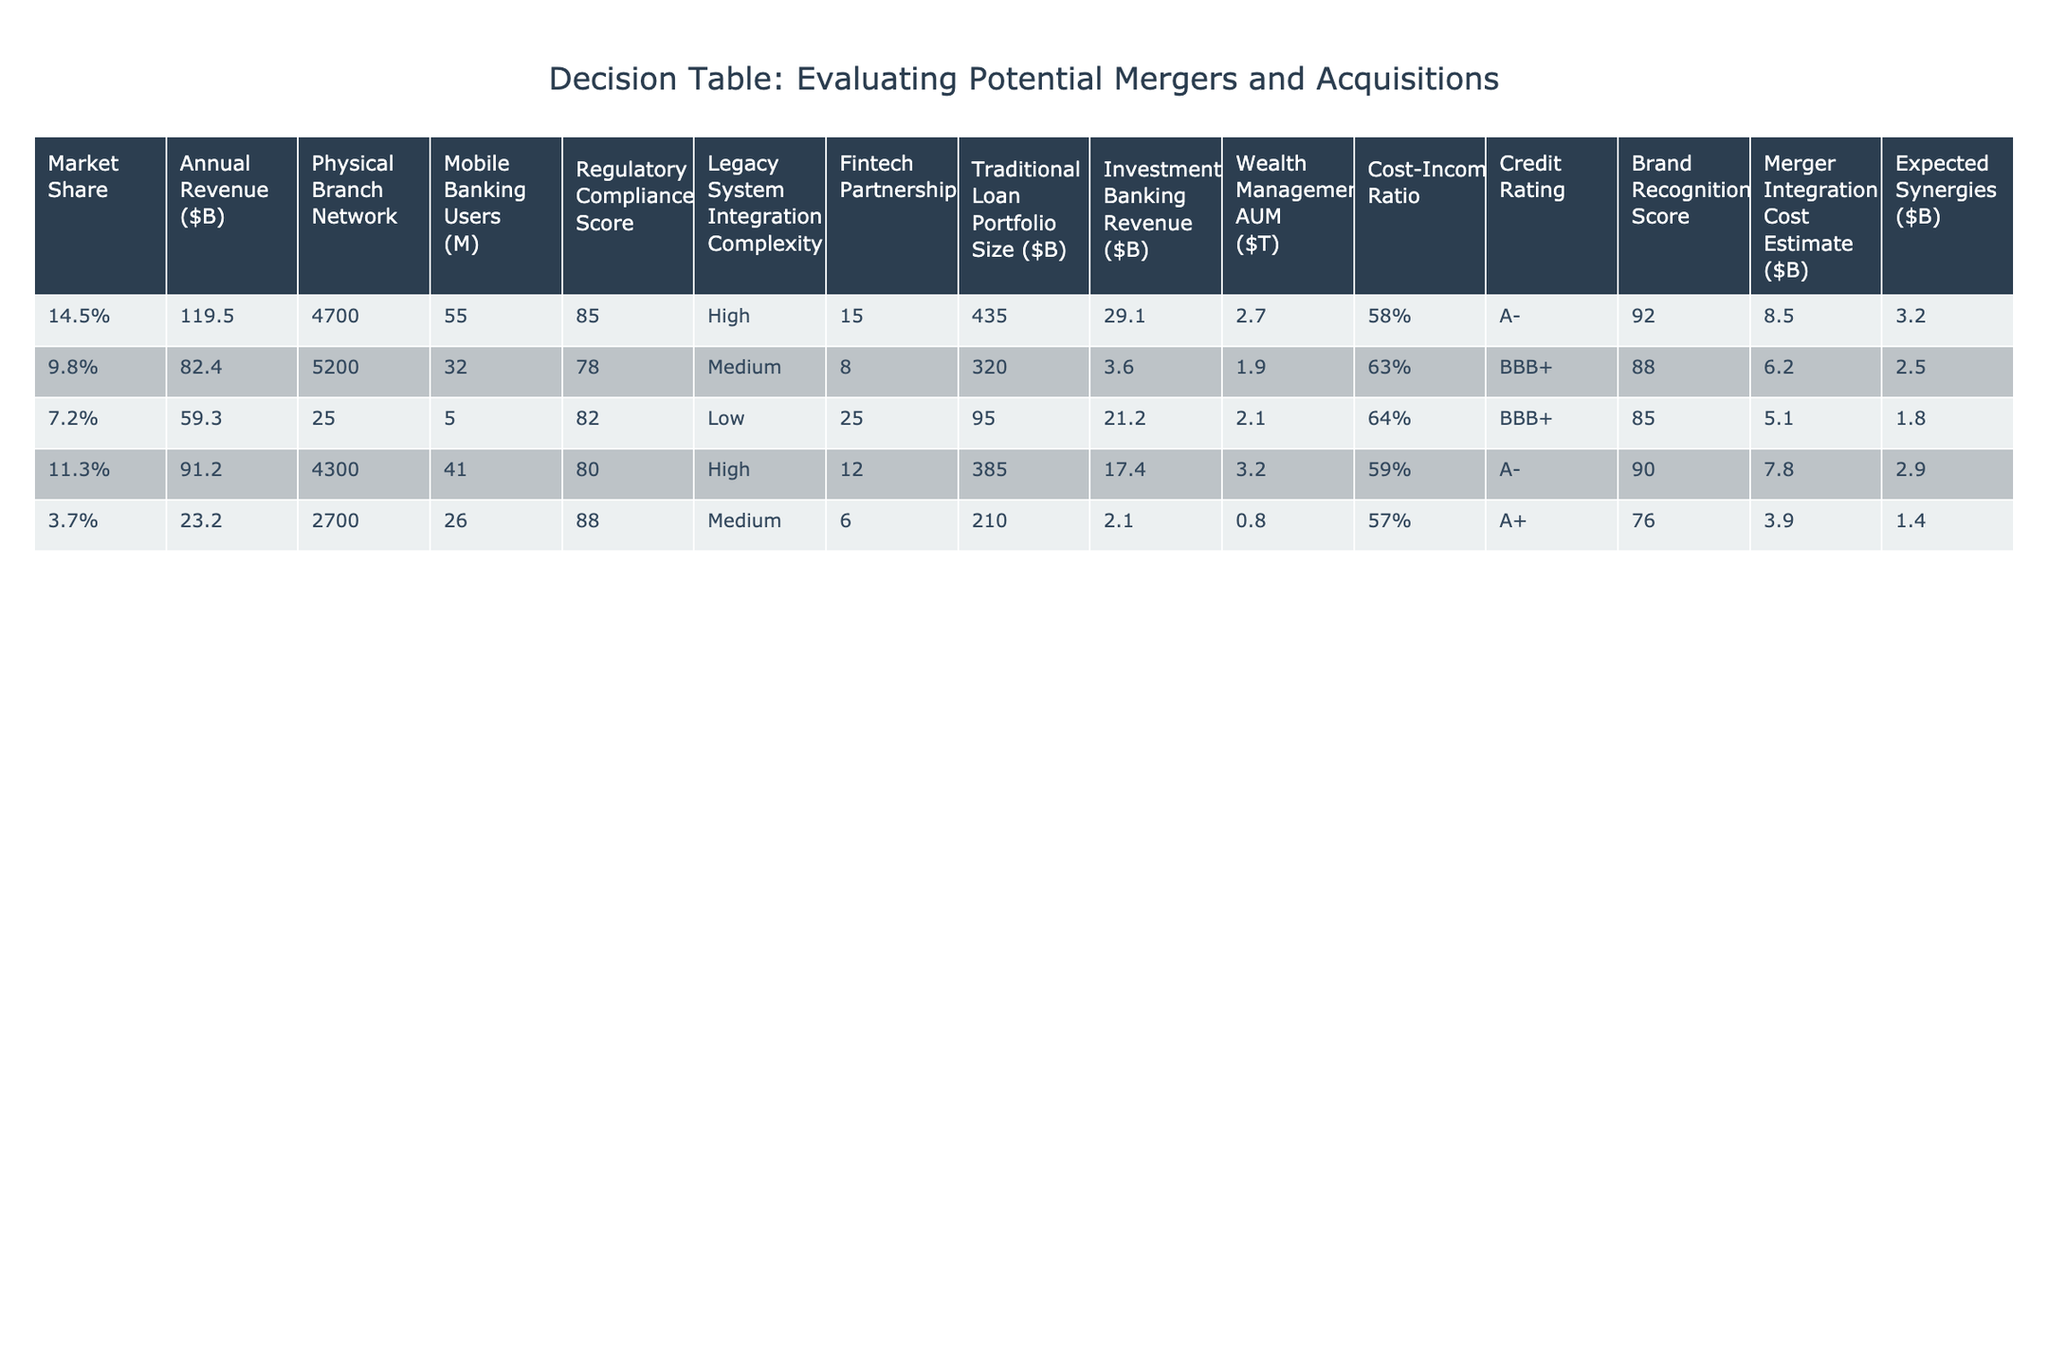What is the market share of Bank of America? From the table, Bank of America's market share is listed as 11.3%.
Answer: 11.3% Which bank has the highest annual revenue? Looking at the annual revenue figures, JP Morgan Chase has the highest revenue at $119.5 billion.
Answer: JP Morgan Chase What is the total number of physical branches for US Bancorp and Goldman Sachs combined? US Bancorp has 2,700 branches and Goldman Sachs has 25 branches. Adding them together (2,700 + 25) equals 2,725 branches.
Answer: 2,725 Is the regulatory compliance score for Wells Fargo higher than that of Bank of America? Wells Fargo's score is 78, and Bank of America's score is 80, making Wells Fargo’s score lower than Bank of America's.
Answer: No Which bank has the lowest cost-to-income ratio? The cost-income ratios are as follows: JP Morgan Chase at 58%, Wells Fargo at 63%, Goldman Sachs at 64%, Bank of America at 59%, and US Bancorp at 57%. Thus, US Bancorp has the lowest ratio at 57%.
Answer: US Bancorp What is the difference in mobile banking users between JP Morgan Chase and Bank of America? JP Morgan Chase has 55 million mobile banking users, while Bank of America has 41 million. The difference is (55 - 41) = 14 million users.
Answer: 14 million Which bank has the highest expected synergies? The expected synergies are: JP Morgan Chase at $3.2 billion, Wells Fargo at $2.5 billion, Goldman Sachs at $1.8 billion, Bank of America at $2.9 billion, and US Bancorp at $1.4 billion. JP Morgan Chase has the highest expected synergies.
Answer: JP Morgan Chase What is the average regulatory compliance score for the banks listed? The scores are 85, 78, 82, 80, and 88. Adding these together gives 413, and dividing by 5 results in an average of 82.6.
Answer: 82.6 Does Goldman Sachs have a higher investment banking revenue than Wells Fargo? Goldman Sachs has $21.2 billion in investment banking revenue, while Wells Fargo has $3.6 billion. Therefore, Goldman Sachs has a higher figure.
Answer: Yes 